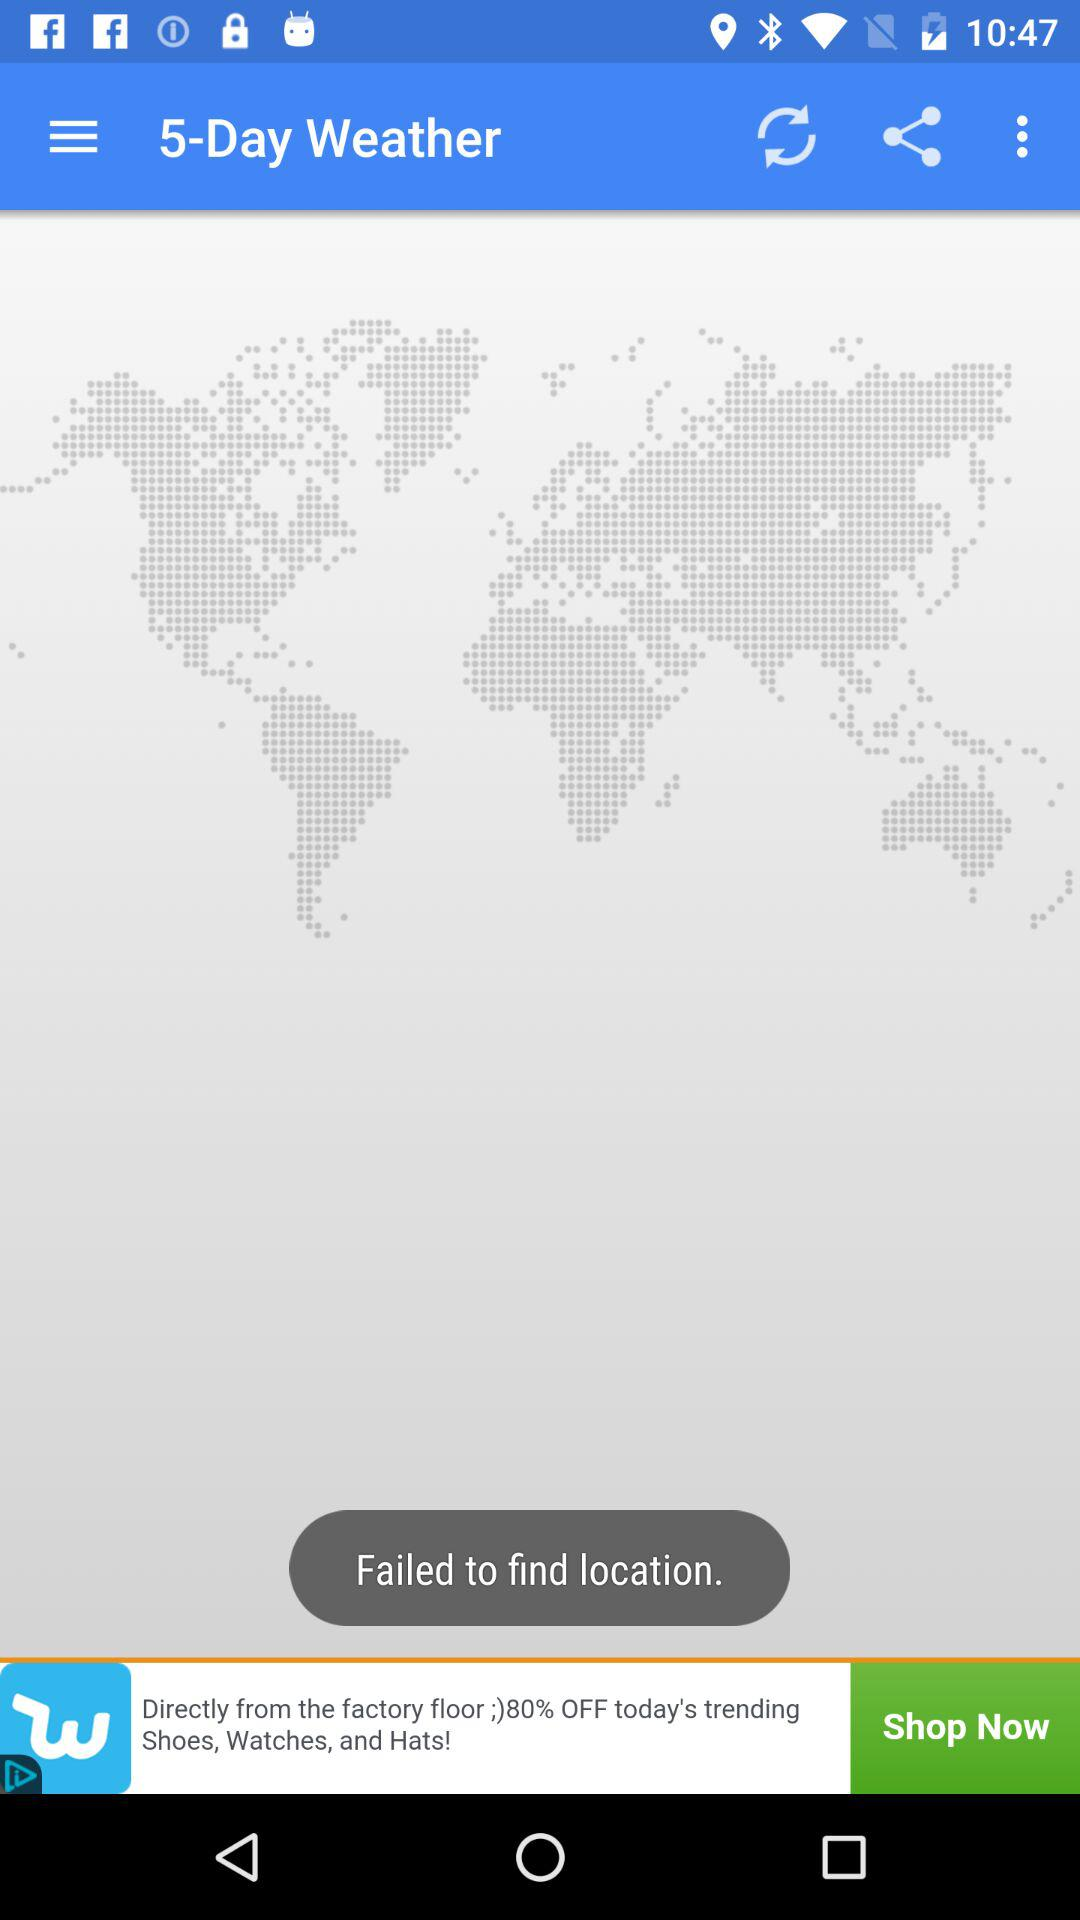How many days of weather is shown here?
When the provided information is insufficient, respond with <no answer>. <no answer> 